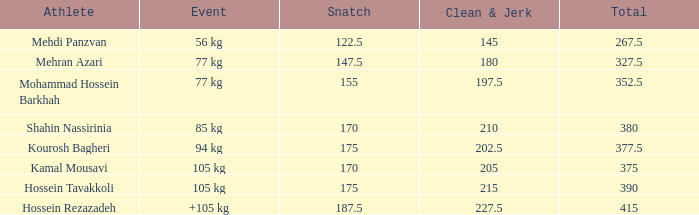What event has a 122.5 snatch rate? 56 kg. 